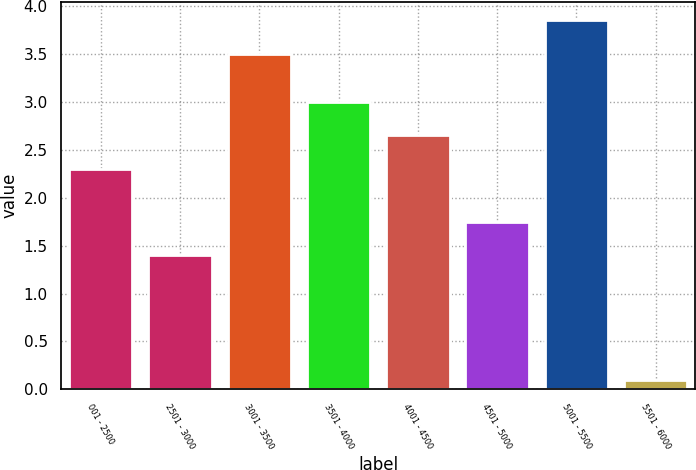Convert chart. <chart><loc_0><loc_0><loc_500><loc_500><bar_chart><fcel>001 - 2500<fcel>2501 - 3000<fcel>3001 - 3500<fcel>3501 - 4000<fcel>4001 - 4500<fcel>4501 - 5000<fcel>5001 - 5500<fcel>5501 - 6000<nl><fcel>2.3<fcel>1.4<fcel>3.5<fcel>3<fcel>2.65<fcel>1.75<fcel>3.85<fcel>0.1<nl></chart> 